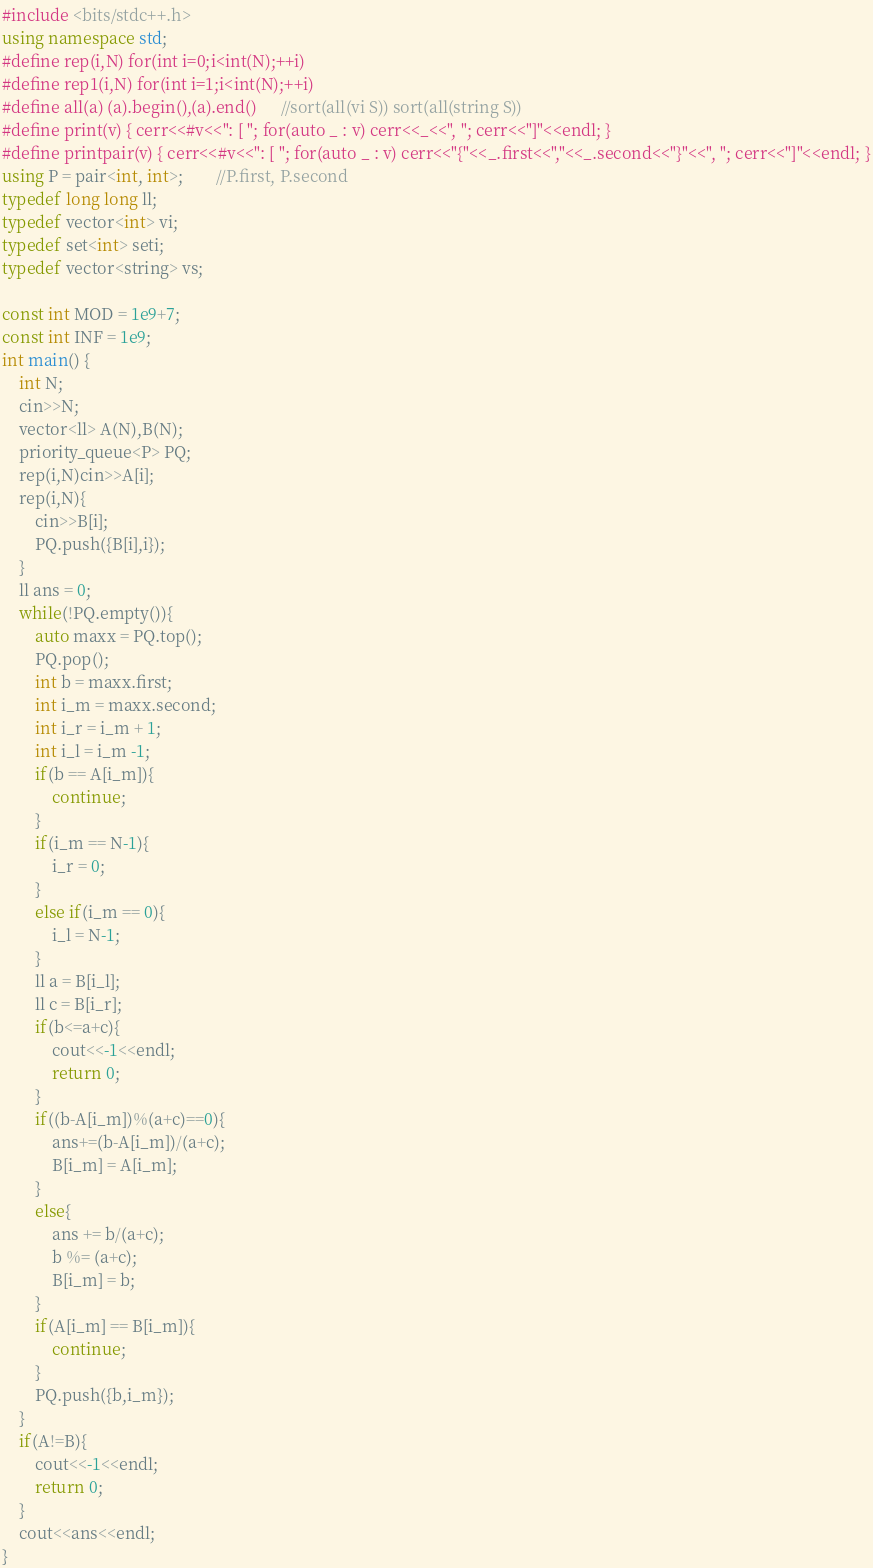Convert code to text. <code><loc_0><loc_0><loc_500><loc_500><_C++_>#include <bits/stdc++.h>
using namespace std;
#define rep(i,N) for(int i=0;i<int(N);++i)
#define rep1(i,N) for(int i=1;i<int(N);++i)
#define all(a) (a).begin(),(a).end()		 //sort(all(vi S)) sort(all(string S))
#define print(v) { cerr<<#v<<": [ "; for(auto _ : v) cerr<<_<<", "; cerr<<"]"<<endl; }
#define printpair(v) { cerr<<#v<<": [ "; for(auto _ : v) cerr<<"{"<<_.first<<","<<_.second<<"}"<<", "; cerr<<"]"<<endl; }
using P = pair<int, int>;		//P.first, P.second
typedef long long ll;
typedef vector<int> vi;
typedef set<int> seti;
typedef vector<string> vs;

const int MOD = 1e9+7;
const int INF = 1e9;
int main() {
    int N;
    cin>>N;
    vector<ll> A(N),B(N);
    priority_queue<P> PQ;
    rep(i,N)cin>>A[i];
    rep(i,N){
        cin>>B[i];
        PQ.push({B[i],i});
    }
    ll ans = 0;
    while(!PQ.empty()){
        auto maxx = PQ.top();
        PQ.pop();
        int b = maxx.first;
        int i_m = maxx.second;
        int i_r = i_m + 1;
        int i_l = i_m -1; 
        if(b == A[i_m]){
            continue;
        }
        if(i_m == N-1){
            i_r = 0;
        }
        else if(i_m == 0){
            i_l = N-1;
        }
        ll a = B[i_l];
        ll c = B[i_r];
        if(b<=a+c){
            cout<<-1<<endl;
            return 0;
        }
        if((b-A[i_m])%(a+c)==0){
            ans+=(b-A[i_m])/(a+c);
            B[i_m] = A[i_m];
        }
        else{
            ans += b/(a+c);
            b %= (a+c);
            B[i_m] = b;
        }
        if(A[i_m] == B[i_m]){
            continue;
        }
        PQ.push({b,i_m});
    }
    if(A!=B){
        cout<<-1<<endl;
        return 0;
    }
    cout<<ans<<endl;
}
</code> 